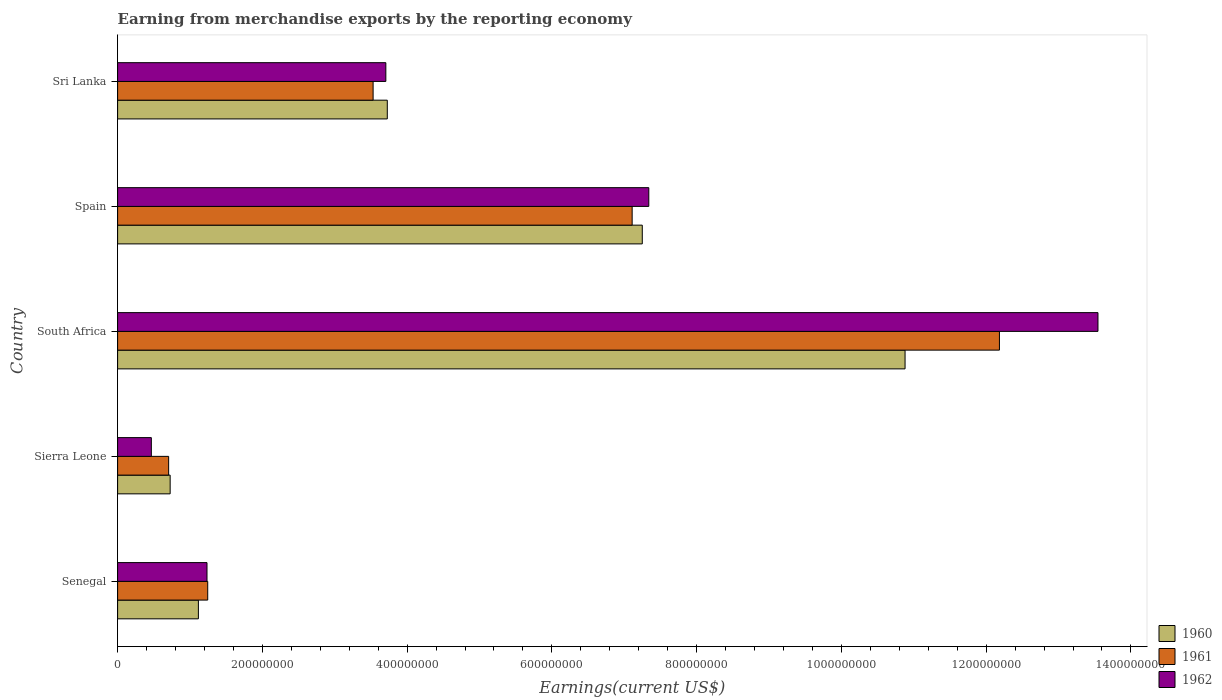How many different coloured bars are there?
Your answer should be very brief. 3. How many groups of bars are there?
Provide a short and direct response. 5. How many bars are there on the 1st tick from the bottom?
Provide a short and direct response. 3. What is the label of the 4th group of bars from the top?
Your answer should be very brief. Sierra Leone. In how many cases, is the number of bars for a given country not equal to the number of legend labels?
Give a very brief answer. 0. What is the amount earned from merchandise exports in 1961 in Sri Lanka?
Your response must be concise. 3.53e+08. Across all countries, what is the maximum amount earned from merchandise exports in 1960?
Give a very brief answer. 1.09e+09. Across all countries, what is the minimum amount earned from merchandise exports in 1960?
Offer a very short reply. 7.26e+07. In which country was the amount earned from merchandise exports in 1960 maximum?
Your answer should be compact. South Africa. In which country was the amount earned from merchandise exports in 1962 minimum?
Your answer should be compact. Sierra Leone. What is the total amount earned from merchandise exports in 1962 in the graph?
Provide a short and direct response. 2.63e+09. What is the difference between the amount earned from merchandise exports in 1961 in South Africa and that in Spain?
Keep it short and to the point. 5.07e+08. What is the difference between the amount earned from merchandise exports in 1960 in Spain and the amount earned from merchandise exports in 1962 in South Africa?
Your answer should be compact. -6.30e+08. What is the average amount earned from merchandise exports in 1962 per country?
Make the answer very short. 5.26e+08. What is the difference between the amount earned from merchandise exports in 1961 and amount earned from merchandise exports in 1960 in Sri Lanka?
Ensure brevity in your answer.  -1.96e+07. In how many countries, is the amount earned from merchandise exports in 1962 greater than 1040000000 US$?
Make the answer very short. 1. What is the ratio of the amount earned from merchandise exports in 1962 in Senegal to that in Sri Lanka?
Your response must be concise. 0.33. Is the amount earned from merchandise exports in 1960 in Senegal less than that in Spain?
Ensure brevity in your answer.  Yes. Is the difference between the amount earned from merchandise exports in 1961 in Sierra Leone and Spain greater than the difference between the amount earned from merchandise exports in 1960 in Sierra Leone and Spain?
Offer a terse response. Yes. What is the difference between the highest and the second highest amount earned from merchandise exports in 1960?
Provide a succinct answer. 3.63e+08. What is the difference between the highest and the lowest amount earned from merchandise exports in 1960?
Offer a terse response. 1.02e+09. How many countries are there in the graph?
Give a very brief answer. 5. Are the values on the major ticks of X-axis written in scientific E-notation?
Provide a short and direct response. No. Does the graph contain any zero values?
Keep it short and to the point. No. Does the graph contain grids?
Keep it short and to the point. No. Where does the legend appear in the graph?
Your answer should be compact. Bottom right. How are the legend labels stacked?
Make the answer very short. Vertical. What is the title of the graph?
Keep it short and to the point. Earning from merchandise exports by the reporting economy. Does "1997" appear as one of the legend labels in the graph?
Make the answer very short. No. What is the label or title of the X-axis?
Ensure brevity in your answer.  Earnings(current US$). What is the label or title of the Y-axis?
Give a very brief answer. Country. What is the Earnings(current US$) of 1960 in Senegal?
Your answer should be very brief. 1.12e+08. What is the Earnings(current US$) of 1961 in Senegal?
Give a very brief answer. 1.24e+08. What is the Earnings(current US$) in 1962 in Senegal?
Offer a terse response. 1.24e+08. What is the Earnings(current US$) in 1960 in Sierra Leone?
Offer a terse response. 7.26e+07. What is the Earnings(current US$) of 1961 in Sierra Leone?
Your response must be concise. 7.05e+07. What is the Earnings(current US$) in 1962 in Sierra Leone?
Ensure brevity in your answer.  4.66e+07. What is the Earnings(current US$) of 1960 in South Africa?
Your answer should be compact. 1.09e+09. What is the Earnings(current US$) of 1961 in South Africa?
Provide a succinct answer. 1.22e+09. What is the Earnings(current US$) in 1962 in South Africa?
Your response must be concise. 1.35e+09. What is the Earnings(current US$) of 1960 in Spain?
Offer a very short reply. 7.25e+08. What is the Earnings(current US$) in 1961 in Spain?
Keep it short and to the point. 7.11e+08. What is the Earnings(current US$) in 1962 in Spain?
Provide a succinct answer. 7.34e+08. What is the Earnings(current US$) in 1960 in Sri Lanka?
Offer a very short reply. 3.73e+08. What is the Earnings(current US$) in 1961 in Sri Lanka?
Make the answer very short. 3.53e+08. What is the Earnings(current US$) of 1962 in Sri Lanka?
Your answer should be compact. 3.71e+08. Across all countries, what is the maximum Earnings(current US$) in 1960?
Your answer should be compact. 1.09e+09. Across all countries, what is the maximum Earnings(current US$) of 1961?
Your answer should be compact. 1.22e+09. Across all countries, what is the maximum Earnings(current US$) of 1962?
Provide a short and direct response. 1.35e+09. Across all countries, what is the minimum Earnings(current US$) in 1960?
Keep it short and to the point. 7.26e+07. Across all countries, what is the minimum Earnings(current US$) of 1961?
Provide a short and direct response. 7.05e+07. Across all countries, what is the minimum Earnings(current US$) of 1962?
Ensure brevity in your answer.  4.66e+07. What is the total Earnings(current US$) of 1960 in the graph?
Provide a short and direct response. 2.37e+09. What is the total Earnings(current US$) of 1961 in the graph?
Provide a succinct answer. 2.48e+09. What is the total Earnings(current US$) in 1962 in the graph?
Provide a short and direct response. 2.63e+09. What is the difference between the Earnings(current US$) in 1960 in Senegal and that in Sierra Leone?
Offer a very short reply. 3.90e+07. What is the difference between the Earnings(current US$) of 1961 in Senegal and that in Sierra Leone?
Make the answer very short. 5.40e+07. What is the difference between the Earnings(current US$) of 1962 in Senegal and that in Sierra Leone?
Offer a very short reply. 7.69e+07. What is the difference between the Earnings(current US$) of 1960 in Senegal and that in South Africa?
Make the answer very short. -9.76e+08. What is the difference between the Earnings(current US$) in 1961 in Senegal and that in South Africa?
Make the answer very short. -1.09e+09. What is the difference between the Earnings(current US$) in 1962 in Senegal and that in South Africa?
Keep it short and to the point. -1.23e+09. What is the difference between the Earnings(current US$) in 1960 in Senegal and that in Spain?
Provide a succinct answer. -6.13e+08. What is the difference between the Earnings(current US$) in 1961 in Senegal and that in Spain?
Offer a very short reply. -5.86e+08. What is the difference between the Earnings(current US$) in 1962 in Senegal and that in Spain?
Offer a very short reply. -6.10e+08. What is the difference between the Earnings(current US$) in 1960 in Senegal and that in Sri Lanka?
Give a very brief answer. -2.61e+08. What is the difference between the Earnings(current US$) of 1961 in Senegal and that in Sri Lanka?
Ensure brevity in your answer.  -2.28e+08. What is the difference between the Earnings(current US$) in 1962 in Senegal and that in Sri Lanka?
Make the answer very short. -2.47e+08. What is the difference between the Earnings(current US$) in 1960 in Sierra Leone and that in South Africa?
Your answer should be compact. -1.02e+09. What is the difference between the Earnings(current US$) of 1961 in Sierra Leone and that in South Africa?
Make the answer very short. -1.15e+09. What is the difference between the Earnings(current US$) of 1962 in Sierra Leone and that in South Africa?
Offer a very short reply. -1.31e+09. What is the difference between the Earnings(current US$) of 1960 in Sierra Leone and that in Spain?
Your answer should be compact. -6.52e+08. What is the difference between the Earnings(current US$) of 1961 in Sierra Leone and that in Spain?
Provide a short and direct response. -6.40e+08. What is the difference between the Earnings(current US$) of 1962 in Sierra Leone and that in Spain?
Provide a short and direct response. -6.87e+08. What is the difference between the Earnings(current US$) of 1960 in Sierra Leone and that in Sri Lanka?
Your response must be concise. -3.00e+08. What is the difference between the Earnings(current US$) of 1961 in Sierra Leone and that in Sri Lanka?
Make the answer very short. -2.82e+08. What is the difference between the Earnings(current US$) of 1962 in Sierra Leone and that in Sri Lanka?
Offer a very short reply. -3.24e+08. What is the difference between the Earnings(current US$) in 1960 in South Africa and that in Spain?
Your answer should be very brief. 3.63e+08. What is the difference between the Earnings(current US$) of 1961 in South Africa and that in Spain?
Your answer should be compact. 5.07e+08. What is the difference between the Earnings(current US$) of 1962 in South Africa and that in Spain?
Ensure brevity in your answer.  6.21e+08. What is the difference between the Earnings(current US$) of 1960 in South Africa and that in Sri Lanka?
Provide a short and direct response. 7.15e+08. What is the difference between the Earnings(current US$) in 1961 in South Africa and that in Sri Lanka?
Ensure brevity in your answer.  8.65e+08. What is the difference between the Earnings(current US$) in 1962 in South Africa and that in Sri Lanka?
Give a very brief answer. 9.84e+08. What is the difference between the Earnings(current US$) of 1960 in Spain and that in Sri Lanka?
Offer a very short reply. 3.52e+08. What is the difference between the Earnings(current US$) of 1961 in Spain and that in Sri Lanka?
Offer a terse response. 3.58e+08. What is the difference between the Earnings(current US$) in 1962 in Spain and that in Sri Lanka?
Give a very brief answer. 3.63e+08. What is the difference between the Earnings(current US$) of 1960 in Senegal and the Earnings(current US$) of 1961 in Sierra Leone?
Keep it short and to the point. 4.11e+07. What is the difference between the Earnings(current US$) of 1960 in Senegal and the Earnings(current US$) of 1962 in Sierra Leone?
Provide a succinct answer. 6.50e+07. What is the difference between the Earnings(current US$) of 1961 in Senegal and the Earnings(current US$) of 1962 in Sierra Leone?
Keep it short and to the point. 7.79e+07. What is the difference between the Earnings(current US$) in 1960 in Senegal and the Earnings(current US$) in 1961 in South Africa?
Provide a short and direct response. -1.11e+09. What is the difference between the Earnings(current US$) in 1960 in Senegal and the Earnings(current US$) in 1962 in South Africa?
Make the answer very short. -1.24e+09. What is the difference between the Earnings(current US$) in 1961 in Senegal and the Earnings(current US$) in 1962 in South Africa?
Make the answer very short. -1.23e+09. What is the difference between the Earnings(current US$) in 1960 in Senegal and the Earnings(current US$) in 1961 in Spain?
Offer a very short reply. -5.99e+08. What is the difference between the Earnings(current US$) of 1960 in Senegal and the Earnings(current US$) of 1962 in Spain?
Offer a terse response. -6.22e+08. What is the difference between the Earnings(current US$) of 1961 in Senegal and the Earnings(current US$) of 1962 in Spain?
Provide a short and direct response. -6.09e+08. What is the difference between the Earnings(current US$) of 1960 in Senegal and the Earnings(current US$) of 1961 in Sri Lanka?
Your response must be concise. -2.41e+08. What is the difference between the Earnings(current US$) of 1960 in Senegal and the Earnings(current US$) of 1962 in Sri Lanka?
Keep it short and to the point. -2.59e+08. What is the difference between the Earnings(current US$) in 1961 in Senegal and the Earnings(current US$) in 1962 in Sri Lanka?
Your answer should be compact. -2.46e+08. What is the difference between the Earnings(current US$) in 1960 in Sierra Leone and the Earnings(current US$) in 1961 in South Africa?
Provide a short and direct response. -1.15e+09. What is the difference between the Earnings(current US$) in 1960 in Sierra Leone and the Earnings(current US$) in 1962 in South Africa?
Provide a short and direct response. -1.28e+09. What is the difference between the Earnings(current US$) of 1961 in Sierra Leone and the Earnings(current US$) of 1962 in South Africa?
Keep it short and to the point. -1.28e+09. What is the difference between the Earnings(current US$) of 1960 in Sierra Leone and the Earnings(current US$) of 1961 in Spain?
Your response must be concise. -6.38e+08. What is the difference between the Earnings(current US$) in 1960 in Sierra Leone and the Earnings(current US$) in 1962 in Spain?
Ensure brevity in your answer.  -6.61e+08. What is the difference between the Earnings(current US$) in 1961 in Sierra Leone and the Earnings(current US$) in 1962 in Spain?
Your answer should be very brief. -6.63e+08. What is the difference between the Earnings(current US$) of 1960 in Sierra Leone and the Earnings(current US$) of 1961 in Sri Lanka?
Your answer should be compact. -2.80e+08. What is the difference between the Earnings(current US$) in 1960 in Sierra Leone and the Earnings(current US$) in 1962 in Sri Lanka?
Ensure brevity in your answer.  -2.98e+08. What is the difference between the Earnings(current US$) of 1961 in Sierra Leone and the Earnings(current US$) of 1962 in Sri Lanka?
Your answer should be very brief. -3.00e+08. What is the difference between the Earnings(current US$) of 1960 in South Africa and the Earnings(current US$) of 1961 in Spain?
Your response must be concise. 3.77e+08. What is the difference between the Earnings(current US$) in 1960 in South Africa and the Earnings(current US$) in 1962 in Spain?
Offer a terse response. 3.54e+08. What is the difference between the Earnings(current US$) of 1961 in South Africa and the Earnings(current US$) of 1962 in Spain?
Offer a very short reply. 4.84e+08. What is the difference between the Earnings(current US$) in 1960 in South Africa and the Earnings(current US$) in 1961 in Sri Lanka?
Make the answer very short. 7.35e+08. What is the difference between the Earnings(current US$) of 1960 in South Africa and the Earnings(current US$) of 1962 in Sri Lanka?
Keep it short and to the point. 7.17e+08. What is the difference between the Earnings(current US$) in 1961 in South Africa and the Earnings(current US$) in 1962 in Sri Lanka?
Ensure brevity in your answer.  8.48e+08. What is the difference between the Earnings(current US$) in 1960 in Spain and the Earnings(current US$) in 1961 in Sri Lanka?
Your answer should be very brief. 3.72e+08. What is the difference between the Earnings(current US$) in 1960 in Spain and the Earnings(current US$) in 1962 in Sri Lanka?
Your response must be concise. 3.54e+08. What is the difference between the Earnings(current US$) in 1961 in Spain and the Earnings(current US$) in 1962 in Sri Lanka?
Give a very brief answer. 3.40e+08. What is the average Earnings(current US$) in 1960 per country?
Keep it short and to the point. 4.74e+08. What is the average Earnings(current US$) of 1961 per country?
Keep it short and to the point. 4.95e+08. What is the average Earnings(current US$) in 1962 per country?
Provide a short and direct response. 5.26e+08. What is the difference between the Earnings(current US$) of 1960 and Earnings(current US$) of 1961 in Senegal?
Make the answer very short. -1.29e+07. What is the difference between the Earnings(current US$) of 1960 and Earnings(current US$) of 1962 in Senegal?
Ensure brevity in your answer.  -1.19e+07. What is the difference between the Earnings(current US$) of 1961 and Earnings(current US$) of 1962 in Senegal?
Ensure brevity in your answer.  1.00e+06. What is the difference between the Earnings(current US$) of 1960 and Earnings(current US$) of 1961 in Sierra Leone?
Ensure brevity in your answer.  2.10e+06. What is the difference between the Earnings(current US$) of 1960 and Earnings(current US$) of 1962 in Sierra Leone?
Provide a succinct answer. 2.60e+07. What is the difference between the Earnings(current US$) of 1961 and Earnings(current US$) of 1962 in Sierra Leone?
Offer a terse response. 2.39e+07. What is the difference between the Earnings(current US$) of 1960 and Earnings(current US$) of 1961 in South Africa?
Provide a short and direct response. -1.30e+08. What is the difference between the Earnings(current US$) of 1960 and Earnings(current US$) of 1962 in South Africa?
Keep it short and to the point. -2.67e+08. What is the difference between the Earnings(current US$) in 1961 and Earnings(current US$) in 1962 in South Africa?
Make the answer very short. -1.36e+08. What is the difference between the Earnings(current US$) in 1960 and Earnings(current US$) in 1961 in Spain?
Ensure brevity in your answer.  1.40e+07. What is the difference between the Earnings(current US$) in 1960 and Earnings(current US$) in 1962 in Spain?
Your answer should be very brief. -9.00e+06. What is the difference between the Earnings(current US$) of 1961 and Earnings(current US$) of 1962 in Spain?
Offer a very short reply. -2.30e+07. What is the difference between the Earnings(current US$) of 1960 and Earnings(current US$) of 1961 in Sri Lanka?
Keep it short and to the point. 1.96e+07. What is the difference between the Earnings(current US$) of 1960 and Earnings(current US$) of 1962 in Sri Lanka?
Provide a short and direct response. 2.00e+06. What is the difference between the Earnings(current US$) of 1961 and Earnings(current US$) of 1962 in Sri Lanka?
Ensure brevity in your answer.  -1.76e+07. What is the ratio of the Earnings(current US$) in 1960 in Senegal to that in Sierra Leone?
Offer a very short reply. 1.54. What is the ratio of the Earnings(current US$) of 1961 in Senegal to that in Sierra Leone?
Offer a terse response. 1.77. What is the ratio of the Earnings(current US$) of 1962 in Senegal to that in Sierra Leone?
Offer a terse response. 2.65. What is the ratio of the Earnings(current US$) of 1960 in Senegal to that in South Africa?
Make the answer very short. 0.1. What is the ratio of the Earnings(current US$) of 1961 in Senegal to that in South Africa?
Offer a terse response. 0.1. What is the ratio of the Earnings(current US$) in 1962 in Senegal to that in South Africa?
Offer a very short reply. 0.09. What is the ratio of the Earnings(current US$) of 1960 in Senegal to that in Spain?
Give a very brief answer. 0.15. What is the ratio of the Earnings(current US$) in 1961 in Senegal to that in Spain?
Make the answer very short. 0.18. What is the ratio of the Earnings(current US$) of 1962 in Senegal to that in Spain?
Offer a terse response. 0.17. What is the ratio of the Earnings(current US$) of 1960 in Senegal to that in Sri Lanka?
Give a very brief answer. 0.3. What is the ratio of the Earnings(current US$) of 1961 in Senegal to that in Sri Lanka?
Ensure brevity in your answer.  0.35. What is the ratio of the Earnings(current US$) of 1962 in Senegal to that in Sri Lanka?
Offer a terse response. 0.33. What is the ratio of the Earnings(current US$) in 1960 in Sierra Leone to that in South Africa?
Keep it short and to the point. 0.07. What is the ratio of the Earnings(current US$) in 1961 in Sierra Leone to that in South Africa?
Provide a short and direct response. 0.06. What is the ratio of the Earnings(current US$) of 1962 in Sierra Leone to that in South Africa?
Offer a very short reply. 0.03. What is the ratio of the Earnings(current US$) of 1960 in Sierra Leone to that in Spain?
Make the answer very short. 0.1. What is the ratio of the Earnings(current US$) of 1961 in Sierra Leone to that in Spain?
Your answer should be very brief. 0.1. What is the ratio of the Earnings(current US$) of 1962 in Sierra Leone to that in Spain?
Make the answer very short. 0.06. What is the ratio of the Earnings(current US$) of 1960 in Sierra Leone to that in Sri Lanka?
Offer a very short reply. 0.19. What is the ratio of the Earnings(current US$) in 1961 in Sierra Leone to that in Sri Lanka?
Offer a terse response. 0.2. What is the ratio of the Earnings(current US$) of 1962 in Sierra Leone to that in Sri Lanka?
Provide a short and direct response. 0.13. What is the ratio of the Earnings(current US$) of 1960 in South Africa to that in Spain?
Provide a succinct answer. 1.5. What is the ratio of the Earnings(current US$) of 1961 in South Africa to that in Spain?
Your answer should be compact. 1.71. What is the ratio of the Earnings(current US$) in 1962 in South Africa to that in Spain?
Offer a terse response. 1.85. What is the ratio of the Earnings(current US$) in 1960 in South Africa to that in Sri Lanka?
Offer a terse response. 2.92. What is the ratio of the Earnings(current US$) in 1961 in South Africa to that in Sri Lanka?
Make the answer very short. 3.45. What is the ratio of the Earnings(current US$) in 1962 in South Africa to that in Sri Lanka?
Provide a succinct answer. 3.65. What is the ratio of the Earnings(current US$) in 1960 in Spain to that in Sri Lanka?
Give a very brief answer. 1.95. What is the ratio of the Earnings(current US$) in 1961 in Spain to that in Sri Lanka?
Provide a short and direct response. 2.01. What is the ratio of the Earnings(current US$) in 1962 in Spain to that in Sri Lanka?
Provide a short and direct response. 1.98. What is the difference between the highest and the second highest Earnings(current US$) in 1960?
Offer a terse response. 3.63e+08. What is the difference between the highest and the second highest Earnings(current US$) in 1961?
Give a very brief answer. 5.07e+08. What is the difference between the highest and the second highest Earnings(current US$) in 1962?
Ensure brevity in your answer.  6.21e+08. What is the difference between the highest and the lowest Earnings(current US$) of 1960?
Provide a succinct answer. 1.02e+09. What is the difference between the highest and the lowest Earnings(current US$) in 1961?
Offer a very short reply. 1.15e+09. What is the difference between the highest and the lowest Earnings(current US$) in 1962?
Offer a terse response. 1.31e+09. 